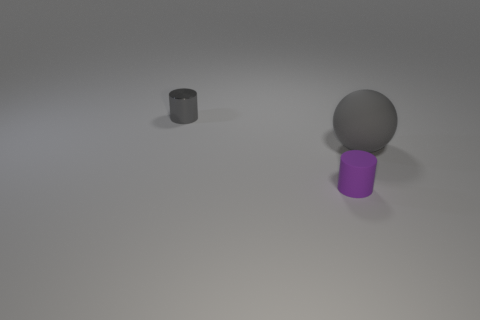Add 3 blue blocks. How many objects exist? 6 Subtract all spheres. How many objects are left? 2 Add 2 small gray metal things. How many small gray metal things are left? 3 Add 2 large yellow metallic balls. How many large yellow metallic balls exist? 2 Subtract 0 red cylinders. How many objects are left? 3 Subtract all small purple cylinders. Subtract all large metallic objects. How many objects are left? 2 